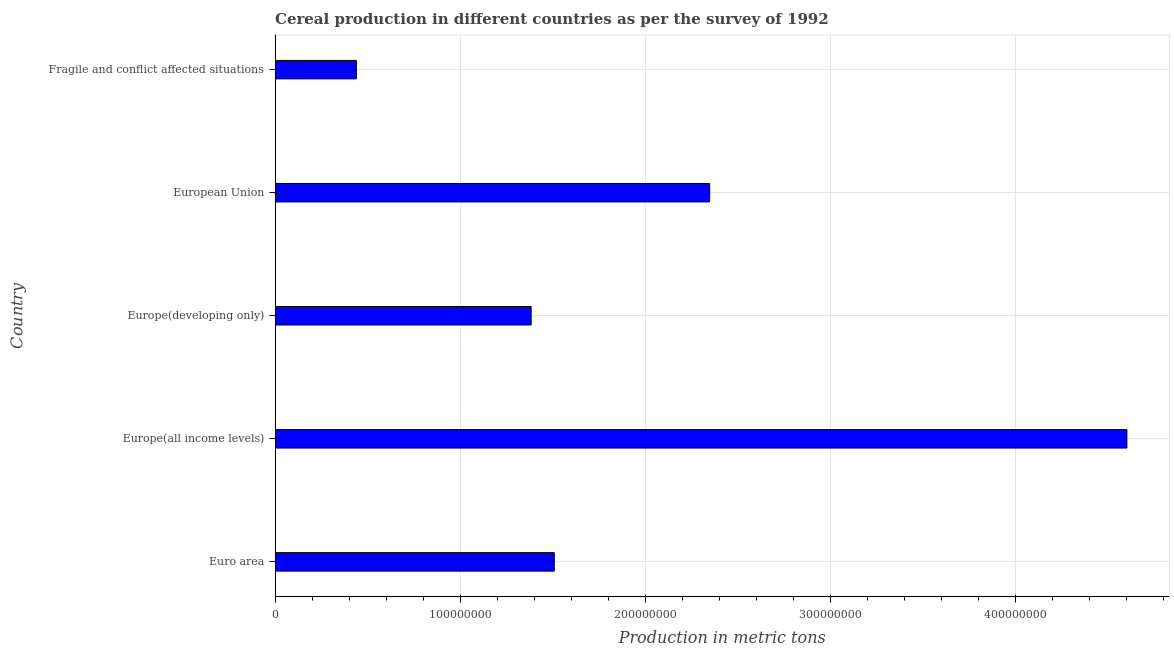Does the graph contain any zero values?
Offer a terse response. No. Does the graph contain grids?
Provide a short and direct response. Yes. What is the title of the graph?
Provide a succinct answer. Cereal production in different countries as per the survey of 1992. What is the label or title of the X-axis?
Your answer should be compact. Production in metric tons. What is the cereal production in Europe(developing only)?
Provide a succinct answer. 1.38e+08. Across all countries, what is the maximum cereal production?
Offer a very short reply. 4.60e+08. Across all countries, what is the minimum cereal production?
Offer a terse response. 4.39e+07. In which country was the cereal production maximum?
Your response must be concise. Europe(all income levels). In which country was the cereal production minimum?
Ensure brevity in your answer.  Fragile and conflict affected situations. What is the sum of the cereal production?
Your answer should be compact. 1.03e+09. What is the difference between the cereal production in Euro area and European Union?
Provide a succinct answer. -8.40e+07. What is the average cereal production per country?
Your answer should be compact. 2.06e+08. What is the median cereal production?
Make the answer very short. 1.51e+08. In how many countries, is the cereal production greater than 240000000 metric tons?
Your answer should be compact. 1. What is the ratio of the cereal production in Euro area to that in European Union?
Provide a succinct answer. 0.64. Is the cereal production in Euro area less than that in Fragile and conflict affected situations?
Your response must be concise. No. Is the difference between the cereal production in Europe(developing only) and Fragile and conflict affected situations greater than the difference between any two countries?
Provide a succinct answer. No. What is the difference between the highest and the second highest cereal production?
Give a very brief answer. 2.26e+08. What is the difference between the highest and the lowest cereal production?
Your answer should be compact. 4.17e+08. In how many countries, is the cereal production greater than the average cereal production taken over all countries?
Make the answer very short. 2. Are all the bars in the graph horizontal?
Provide a succinct answer. Yes. Are the values on the major ticks of X-axis written in scientific E-notation?
Your response must be concise. No. What is the Production in metric tons in Euro area?
Give a very brief answer. 1.51e+08. What is the Production in metric tons in Europe(all income levels)?
Offer a very short reply. 4.60e+08. What is the Production in metric tons in Europe(developing only)?
Your answer should be compact. 1.38e+08. What is the Production in metric tons of European Union?
Offer a very short reply. 2.35e+08. What is the Production in metric tons in Fragile and conflict affected situations?
Provide a short and direct response. 4.39e+07. What is the difference between the Production in metric tons in Euro area and Europe(all income levels)?
Your answer should be compact. -3.10e+08. What is the difference between the Production in metric tons in Euro area and Europe(developing only)?
Offer a very short reply. 1.25e+07. What is the difference between the Production in metric tons in Euro area and European Union?
Your answer should be very brief. -8.40e+07. What is the difference between the Production in metric tons in Euro area and Fragile and conflict affected situations?
Offer a very short reply. 1.07e+08. What is the difference between the Production in metric tons in Europe(all income levels) and Europe(developing only)?
Keep it short and to the point. 3.22e+08. What is the difference between the Production in metric tons in Europe(all income levels) and European Union?
Provide a short and direct response. 2.26e+08. What is the difference between the Production in metric tons in Europe(all income levels) and Fragile and conflict affected situations?
Keep it short and to the point. 4.17e+08. What is the difference between the Production in metric tons in Europe(developing only) and European Union?
Give a very brief answer. -9.65e+07. What is the difference between the Production in metric tons in Europe(developing only) and Fragile and conflict affected situations?
Offer a terse response. 9.45e+07. What is the difference between the Production in metric tons in European Union and Fragile and conflict affected situations?
Give a very brief answer. 1.91e+08. What is the ratio of the Production in metric tons in Euro area to that in Europe(all income levels)?
Ensure brevity in your answer.  0.33. What is the ratio of the Production in metric tons in Euro area to that in Europe(developing only)?
Provide a short and direct response. 1.09. What is the ratio of the Production in metric tons in Euro area to that in European Union?
Keep it short and to the point. 0.64. What is the ratio of the Production in metric tons in Euro area to that in Fragile and conflict affected situations?
Offer a terse response. 3.44. What is the ratio of the Production in metric tons in Europe(all income levels) to that in Europe(developing only)?
Provide a short and direct response. 3.33. What is the ratio of the Production in metric tons in Europe(all income levels) to that in European Union?
Offer a terse response. 1.96. What is the ratio of the Production in metric tons in Europe(all income levels) to that in Fragile and conflict affected situations?
Provide a short and direct response. 10.48. What is the ratio of the Production in metric tons in Europe(developing only) to that in European Union?
Provide a short and direct response. 0.59. What is the ratio of the Production in metric tons in Europe(developing only) to that in Fragile and conflict affected situations?
Your response must be concise. 3.15. What is the ratio of the Production in metric tons in European Union to that in Fragile and conflict affected situations?
Your response must be concise. 5.35. 